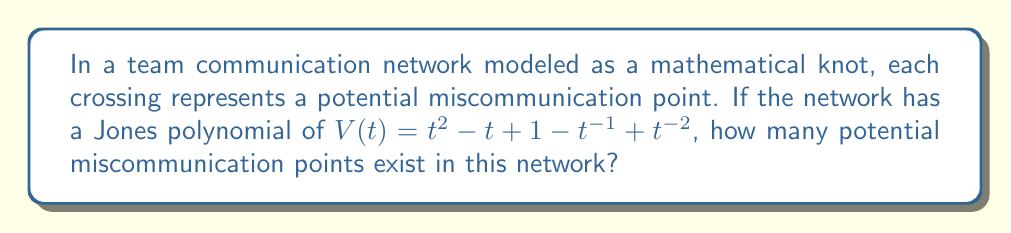Help me with this question. To solve this problem, we need to understand the relationship between the Jones polynomial and the number of crossings in a knot:

1. The Jones polynomial is a knot invariant that can provide information about the knot's structure.

2. For a given Jones polynomial $V(t)$, the number of terms in the polynomial (excluding the constant term) is related to the number of crossings in the knot.

3. Each term in the Jones polynomial corresponds to a potential crossing, with the constant term (in this case, 1) not counted.

4. In the given Jones polynomial:
   $V(t) = t^2 - t + 1 - t^{-1} + t^{-2}$

5. Counting the terms:
   - $t^2$ (1 term)
   - $-t$ (1 term)
   - $1$ (constant term, not counted)
   - $-t^{-1}$ (1 term)
   - $t^{-2}$ (1 term)

6. Total number of terms (excluding constant): 4

Therefore, the number of potential miscommunication points (crossings) in this team communication network is 4.
Answer: 4 